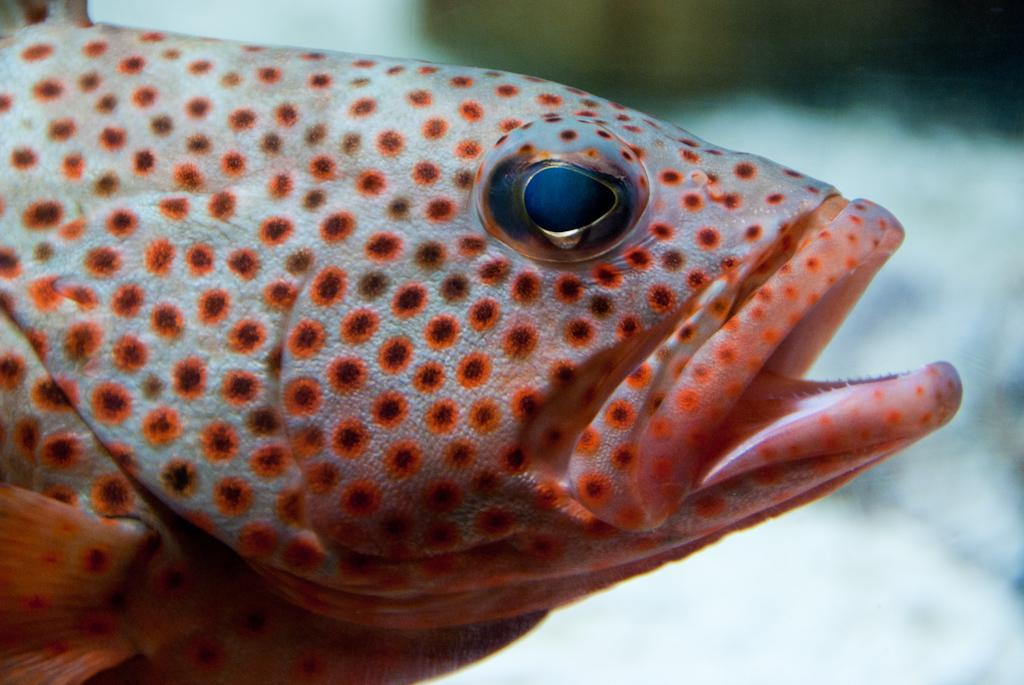What is the main subject of the picture? There is a fish in the picture. Can you describe the background of the image? The background of the image is blurry. What type of stocking is the fish wearing in the image? There is no stocking present in the image, as the subject is a fish. What color is the dress worn by the fish in the image? There is no dress present in the image, as the subject is a fish. 